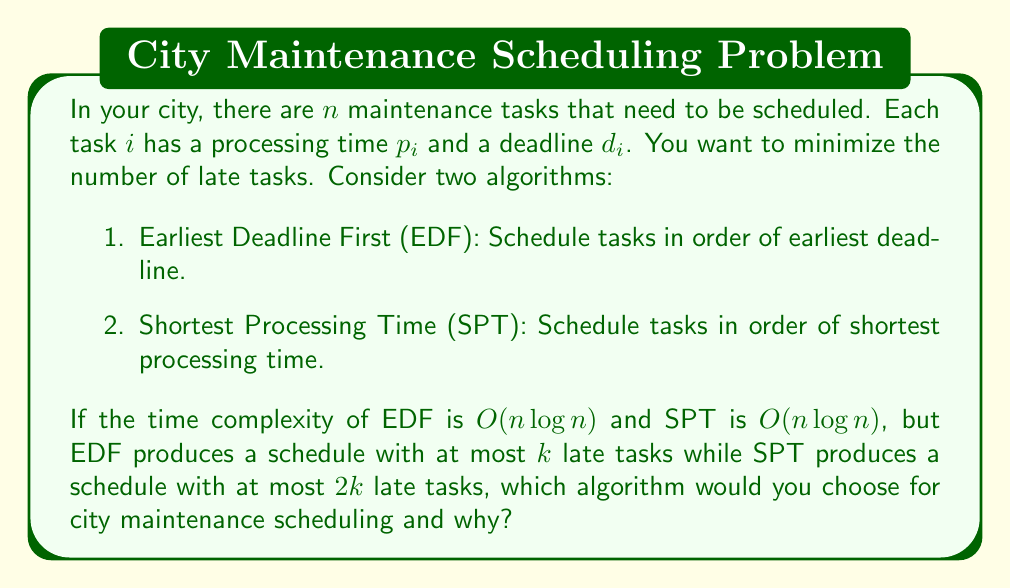Can you answer this question? To answer this question, we need to consider both the time complexity and the effectiveness of the algorithms in minimizing late tasks.

1. Time Complexity:
   Both EDF and SPT have a time complexity of $O(n \log n)$. This is typically due to the sorting step required in both algorithms. The $O(n \log n)$ complexity means that as the number of tasks increases, the time taken to schedule them grows logarithmically. This is considered efficient for sorting-based algorithms.

2. Effectiveness:
   EDF produces a schedule with at most $k$ late tasks.
   SPT produces a schedule with at most $2k$ late tasks.

   Let's define the approximation ratio:
   $$\text{Approximation Ratio} = \frac{\text{Algorithm's solution}}{\text{Optimal solution}}$$

   For EDF: $\frac{k}{k} = 1$
   For SPT: $\frac{2k}{k} = 2$

   This means EDF provides an optimal solution, while SPT provides a 2-approximation.

3. Decision Factors:
   a) Time Efficiency: Both algorithms have the same time complexity, so this is not a differentiating factor.
   b) Solution Quality: EDF produces a better schedule with fewer late tasks.
   c) Budget Implications: Fewer late tasks likely mean less overtime pay, fewer complaints, and more efficient use of resources.

Given that both algorithms have the same time complexity, but EDF produces significantly better results (potentially halving the number of late tasks compared to SPT), EDF is the clear choice for city maintenance scheduling.

The reduction in late tasks from $2k$ to $k$ could lead to substantial cost savings and improved citizen satisfaction, which are key concerns for a mayor overseeing the city budget and municipal spending.
Answer: Choose the Earliest Deadline First (EDF) algorithm. It has the same time complexity as Shortest Processing Time (SPT) but produces a schedule with half as many late tasks in the worst case, leading to potential cost savings and improved efficiency in city maintenance operations. 